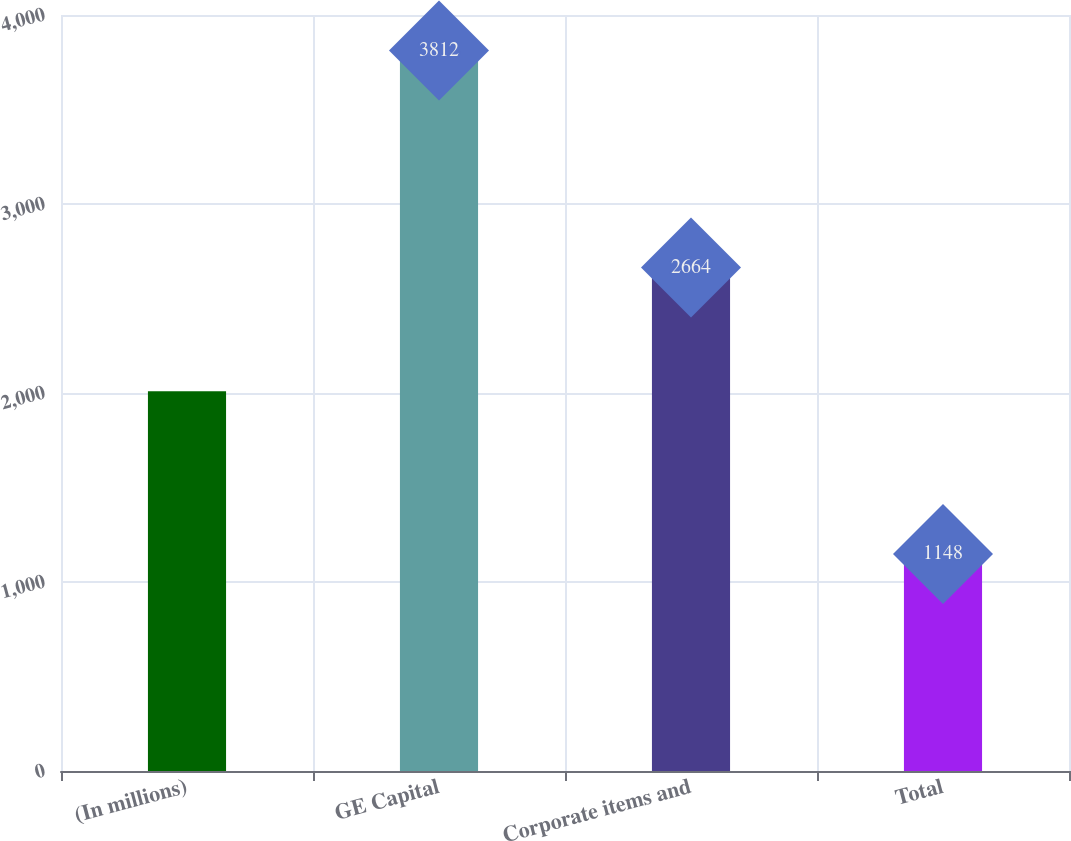Convert chart to OTSL. <chart><loc_0><loc_0><loc_500><loc_500><bar_chart><fcel>(In millions)<fcel>GE Capital<fcel>Corporate items and<fcel>Total<nl><fcel>2009<fcel>3812<fcel>2664<fcel>1148<nl></chart> 